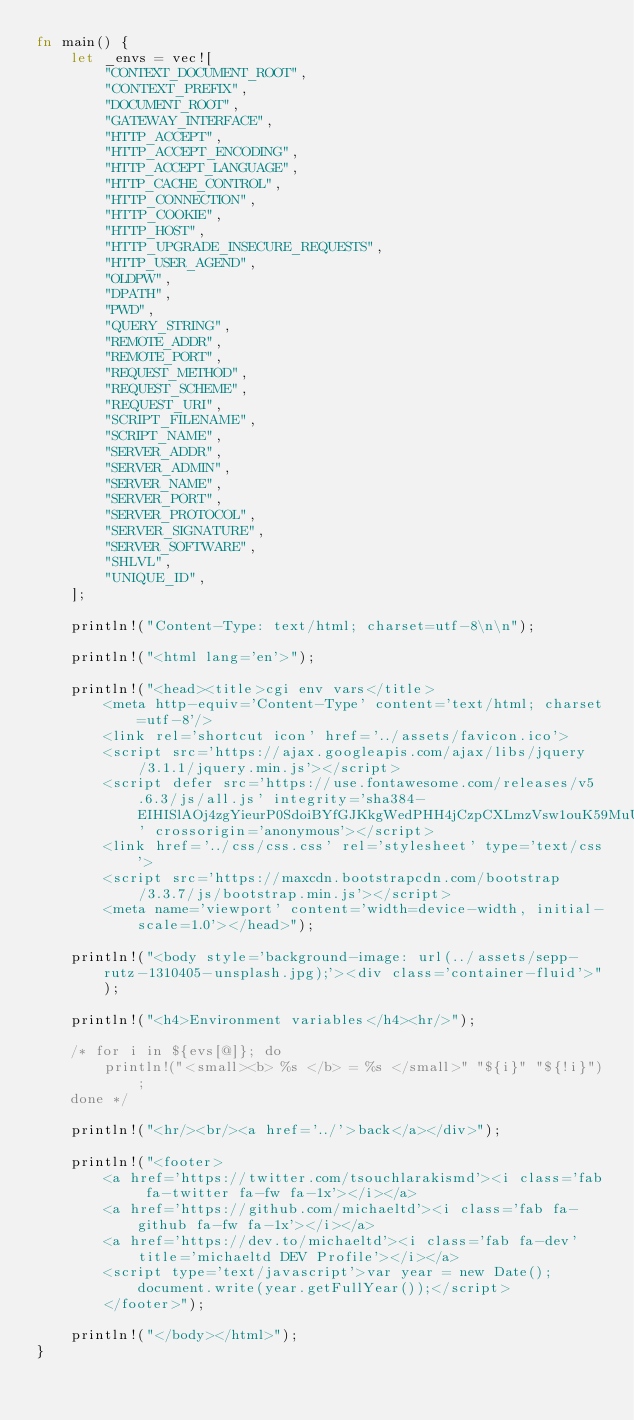<code> <loc_0><loc_0><loc_500><loc_500><_Rust_>fn main() {
    let _envs = vec![
        "CONTEXT_DOCUMENT_ROOT",
        "CONTEXT_PREFIX",
        "DOCUMENT_ROOT",
        "GATEWAY_INTERFACE",
        "HTTP_ACCEPT",
        "HTTP_ACCEPT_ENCODING",
        "HTTP_ACCEPT_LANGUAGE",
        "HTTP_CACHE_CONTROL",
        "HTTP_CONNECTION",
        "HTTP_COOKIE",
        "HTTP_HOST",
        "HTTP_UPGRADE_INSECURE_REQUESTS",
        "HTTP_USER_AGEND",
        "OLDPW",
        "DPATH",
        "PWD",
        "QUERY_STRING",
        "REMOTE_ADDR",
        "REMOTE_PORT",
        "REQUEST_METHOD",
        "REQUEST_SCHEME",
        "REQUEST_URI",
        "SCRIPT_FILENAME",
        "SCRIPT_NAME",
        "SERVER_ADDR",
        "SERVER_ADMIN",
        "SERVER_NAME",
        "SERVER_PORT",
        "SERVER_PROTOCOL",
        "SERVER_SIGNATURE",
        "SERVER_SOFTWARE",
        "SHLVL",
        "UNIQUE_ID",
    ];

    println!("Content-Type: text/html; charset=utf-8\n\n");

    println!("<html lang='en'>");

    println!("<head><title>cgi env vars</title>
        <meta http-equiv='Content-Type' content='text/html; charset=utf-8'/>
        <link rel='shortcut icon' href='../assets/favicon.ico'>
        <script src='https://ajax.googleapis.com/ajax/libs/jquery/3.1.1/jquery.min.js'></script>
        <script defer src='https://use.fontawesome.com/releases/v5.6.3/js/all.js' integrity='sha384-EIHISlAOj4zgYieurP0SdoiBYfGJKkgWedPHH4jCzpCXLmzVsw1ouK59MuUtP4a1' crossorigin='anonymous'></script>
        <link href='../css/css.css' rel='stylesheet' type='text/css'>
        <script src='https://maxcdn.bootstrapcdn.com/bootstrap/3.3.7/js/bootstrap.min.js'></script>
        <meta name='viewport' content='width=device-width, initial-scale=1.0'></head>");

    println!("<body style='background-image: url(../assets/sepp-rutz-1310405-unsplash.jpg);'><div class='container-fluid'>");

    println!("<h4>Environment variables</h4><hr/>");

    /* for i in ${evs[@]}; do
        println!("<small><b> %s </b> = %s </small>" "${i}" "${!i}");
    done */

    println!("<hr/><br/><a href='../'>back</a></div>");

    println!("<footer>
        <a href='https://twitter.com/tsouchlarakismd'><i class='fab fa-twitter fa-fw fa-1x'></i></a>
        <a href='https://github.com/michaeltd'><i class='fab fa-github fa-fw fa-1x'></i></a>
        <a href='https://dev.to/michaeltd'><i class='fab fa-dev' title='michaeltd DEV Profile'></i></a>
        <script type='text/javascript'>var year = new Date();document.write(year.getFullYear());</script>
        </footer>");

    println!("</body></html>");
}
</code> 